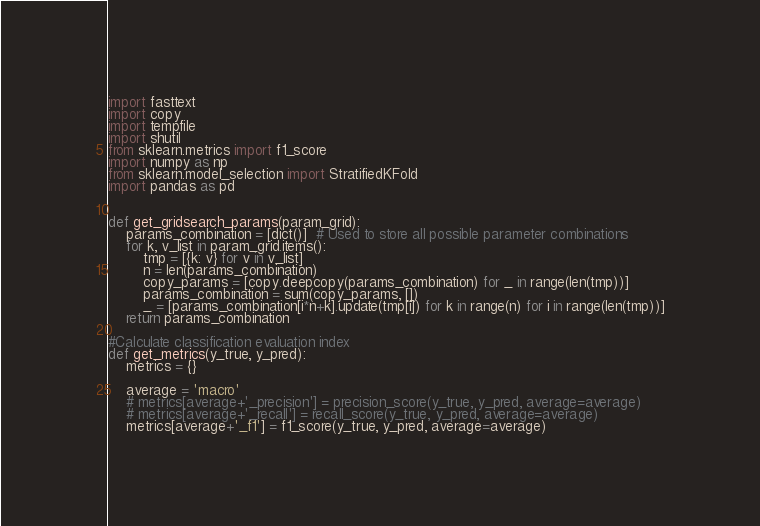<code> <loc_0><loc_0><loc_500><loc_500><_Python_>import fasttext
import copy
import tempfile
import shutil
from sklearn.metrics import f1_score
import numpy as np
from sklearn.model_selection import StratifiedKFold
import pandas as pd


def get_gridsearch_params(param_grid):
    params_combination = [dict()]  # Used to store all possible parameter combinations
    for k, v_list in param_grid.items():
        tmp = [{k: v} for v in v_list]
        n = len(params_combination)
        copy_params = [copy.deepcopy(params_combination) for _ in range(len(tmp))] 
        params_combination = sum(copy_params, [])
        _ = [params_combination[i*n+k].update(tmp[i]) for k in range(n) for i in range(len(tmp))]
    return params_combination

#Calculate classification evaluation index
def get_metrics(y_true, y_pred):
    metrics = {}

    average = 'macro'
    # metrics[average+'_precision'] = precision_score(y_true, y_pred, average=average)
    # metrics[average+'_recall'] = recall_score(y_true, y_pred, average=average)
    metrics[average+'_f1'] = f1_score(y_true, y_pred, average=average)  </code> 